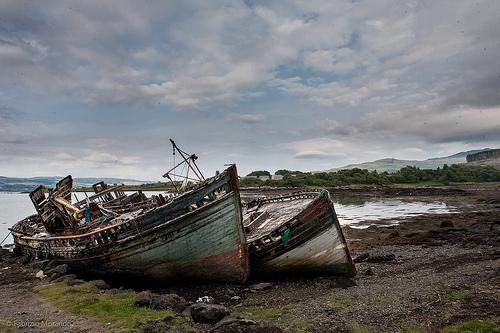Based on the image, what other types of objects besides shipwrecks are present in the image? Besides shipwrecks, there are old boats, black rocks, and white marks in the image. Identify the dominant objects in the image and their surrounding environment. There are old shipwrecks and boats on the sea or bay, with some black rocks and white marks spotted in the vicinity. Count the number of shipwrecks mentioned in the image. There are 6 shipwrecks mentioned in the image. Briefly describe the content of the image, mentioning the main object and its context. The image features old shipwrecks and boats on a sea or bay, with black rocks and white marks scattered around. What type of task focuses on understanding the emotions or feelings conveyed by the image? The image sentiment analysis task focuses on understanding the emotions or feelings conveyed by the image. How many times does the black rock appear in the image? Please provide a number. The black rock appears 9 times in the image. What task involves determining how different objects in the image may interact with one another? The object interaction analysis task involves determining how different objects in the image may interact with one another. Can you provide an example of a question relating to the image content for the VQA task? What is the appearance or condition of the boats and shipwrecks in the image? Determine the environment or setting where the main objects are found in the image. The main objects, including shipwrecks and old boats, are found in a sea or bay environment. What type of task involves answering questions about the content of an image? The VQA (Visual Question Answering) task involves answering questions about the content of an image. 